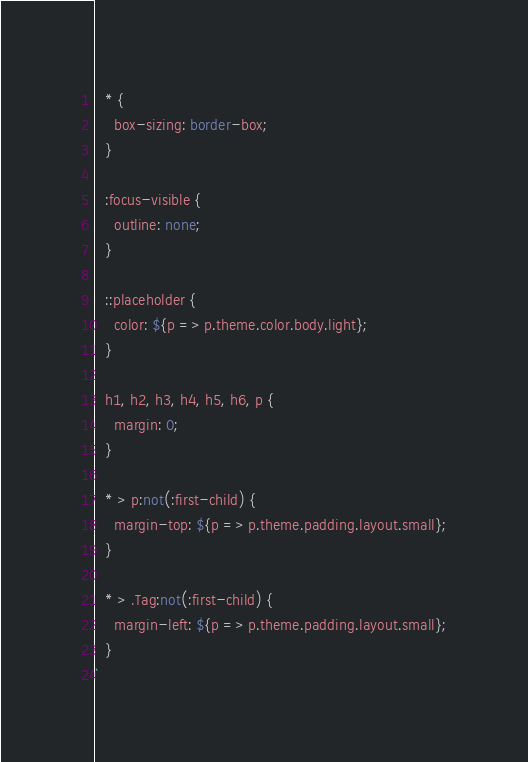<code> <loc_0><loc_0><loc_500><loc_500><_TypeScript_>  * {
    box-sizing: border-box;
  }

  :focus-visible {
    outline: none;
  }

  ::placeholder {
    color: ${p => p.theme.color.body.light};
  }

  h1, h2, h3, h4, h5, h6, p {
    margin: 0;
  }

  * > p:not(:first-child) {
    margin-top: ${p => p.theme.padding.layout.small};
  }

  * > .Tag:not(:first-child) {
    margin-left: ${p => p.theme.padding.layout.small};
  }
`
</code> 